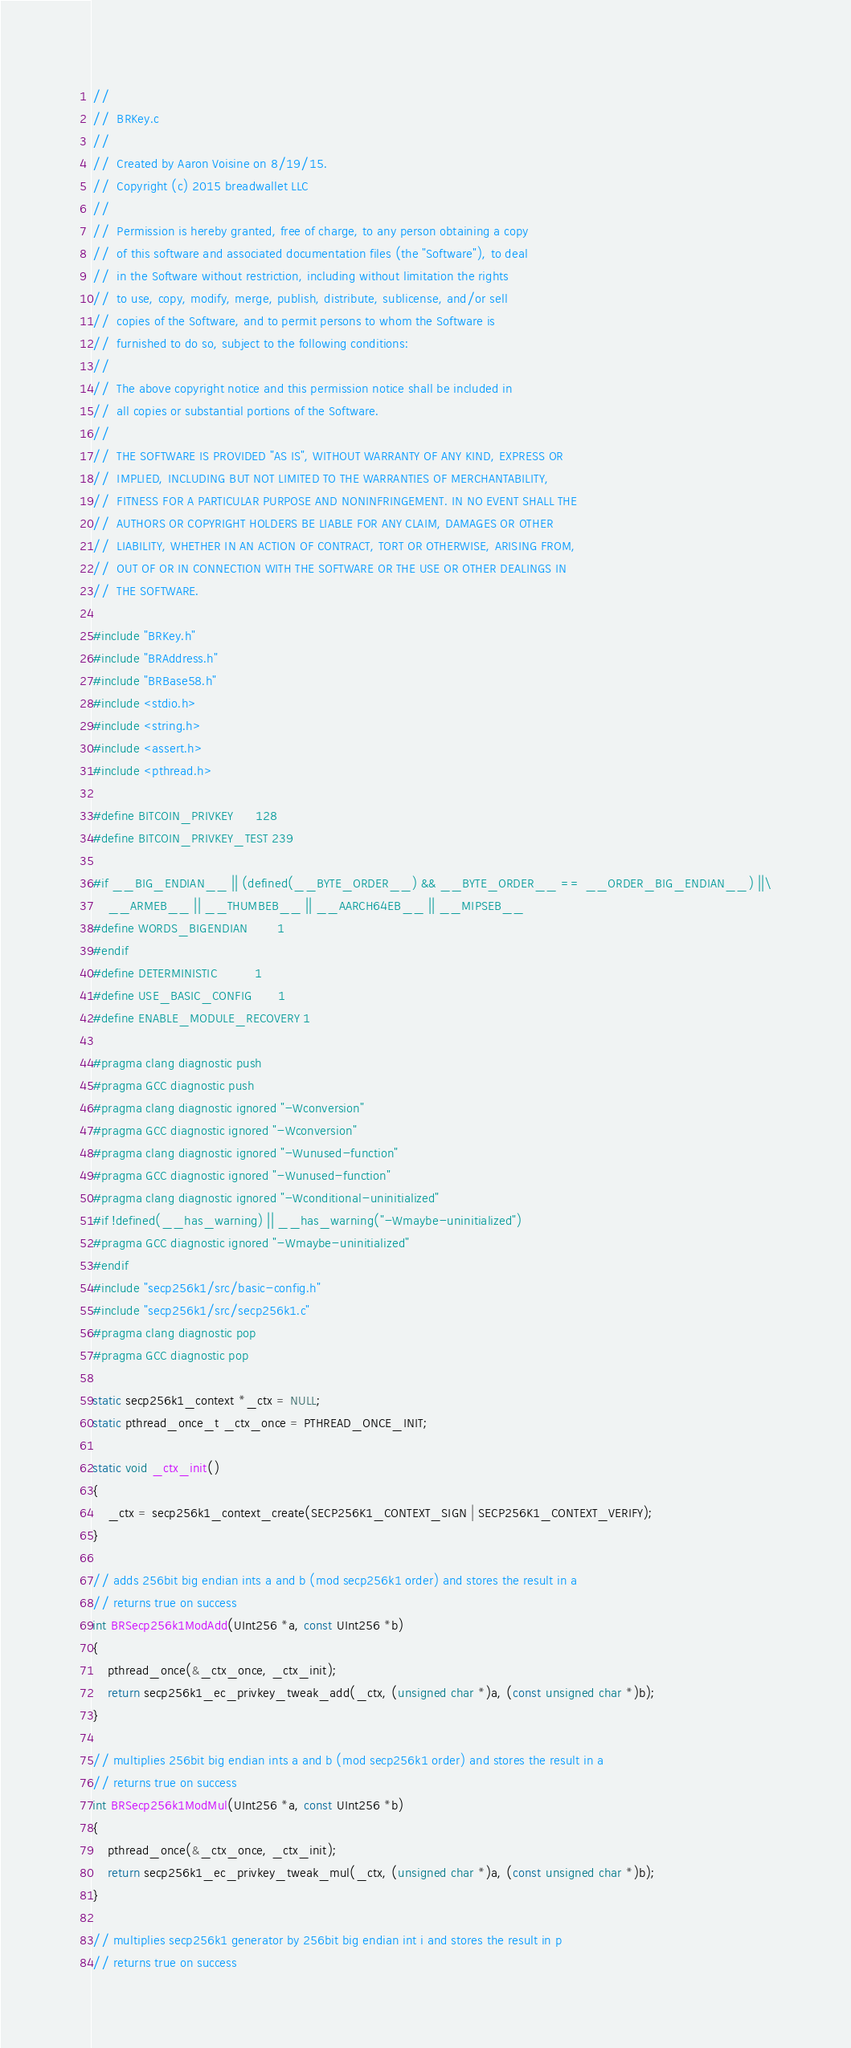<code> <loc_0><loc_0><loc_500><loc_500><_C_>//
//  BRKey.c
//
//  Created by Aaron Voisine on 8/19/15.
//  Copyright (c) 2015 breadwallet LLC
//
//  Permission is hereby granted, free of charge, to any person obtaining a copy
//  of this software and associated documentation files (the "Software"), to deal
//  in the Software without restriction, including without limitation the rights
//  to use, copy, modify, merge, publish, distribute, sublicense, and/or sell
//  copies of the Software, and to permit persons to whom the Software is
//  furnished to do so, subject to the following conditions:
//
//  The above copyright notice and this permission notice shall be included in
//  all copies or substantial portions of the Software.
//
//  THE SOFTWARE IS PROVIDED "AS IS", WITHOUT WARRANTY OF ANY KIND, EXPRESS OR
//  IMPLIED, INCLUDING BUT NOT LIMITED TO THE WARRANTIES OF MERCHANTABILITY,
//  FITNESS FOR A PARTICULAR PURPOSE AND NONINFRINGEMENT. IN NO EVENT SHALL THE
//  AUTHORS OR COPYRIGHT HOLDERS BE LIABLE FOR ANY CLAIM, DAMAGES OR OTHER
//  LIABILITY, WHETHER IN AN ACTION OF CONTRACT, TORT OR OTHERWISE, ARISING FROM,
//  OUT OF OR IN CONNECTION WITH THE SOFTWARE OR THE USE OR OTHER DEALINGS IN
//  THE SOFTWARE.

#include "BRKey.h"
#include "BRAddress.h"
#include "BRBase58.h"
#include <stdio.h>
#include <string.h>
#include <assert.h>
#include <pthread.h>

#define BITCOIN_PRIVKEY      128
#define BITCOIN_PRIVKEY_TEST 239

#if __BIG_ENDIAN__ || (defined(__BYTE_ORDER__) && __BYTE_ORDER__ == __ORDER_BIG_ENDIAN__) ||\
    __ARMEB__ || __THUMBEB__ || __AARCH64EB__ || __MIPSEB__
#define WORDS_BIGENDIAN        1
#endif
#define DETERMINISTIC          1
#define USE_BASIC_CONFIG       1
#define ENABLE_MODULE_RECOVERY 1

#pragma clang diagnostic push
#pragma GCC diagnostic push
#pragma clang diagnostic ignored "-Wconversion"
#pragma GCC diagnostic ignored "-Wconversion"
#pragma clang diagnostic ignored "-Wunused-function"
#pragma GCC diagnostic ignored "-Wunused-function"
#pragma clang diagnostic ignored "-Wconditional-uninitialized"
#if !defined(__has_warning) || __has_warning("-Wmaybe-uninitialized")
#pragma GCC diagnostic ignored "-Wmaybe-uninitialized"
#endif
#include "secp256k1/src/basic-config.h"
#include "secp256k1/src/secp256k1.c"
#pragma clang diagnostic pop
#pragma GCC diagnostic pop

static secp256k1_context *_ctx = NULL;
static pthread_once_t _ctx_once = PTHREAD_ONCE_INIT;

static void _ctx_init()
{
    _ctx = secp256k1_context_create(SECP256K1_CONTEXT_SIGN | SECP256K1_CONTEXT_VERIFY);
}

// adds 256bit big endian ints a and b (mod secp256k1 order) and stores the result in a
// returns true on success
int BRSecp256k1ModAdd(UInt256 *a, const UInt256 *b)
{
    pthread_once(&_ctx_once, _ctx_init);
    return secp256k1_ec_privkey_tweak_add(_ctx, (unsigned char *)a, (const unsigned char *)b);
}

// multiplies 256bit big endian ints a and b (mod secp256k1 order) and stores the result in a
// returns true on success
int BRSecp256k1ModMul(UInt256 *a, const UInt256 *b)
{
    pthread_once(&_ctx_once, _ctx_init);
    return secp256k1_ec_privkey_tweak_mul(_ctx, (unsigned char *)a, (const unsigned char *)b);
}

// multiplies secp256k1 generator by 256bit big endian int i and stores the result in p
// returns true on success</code> 